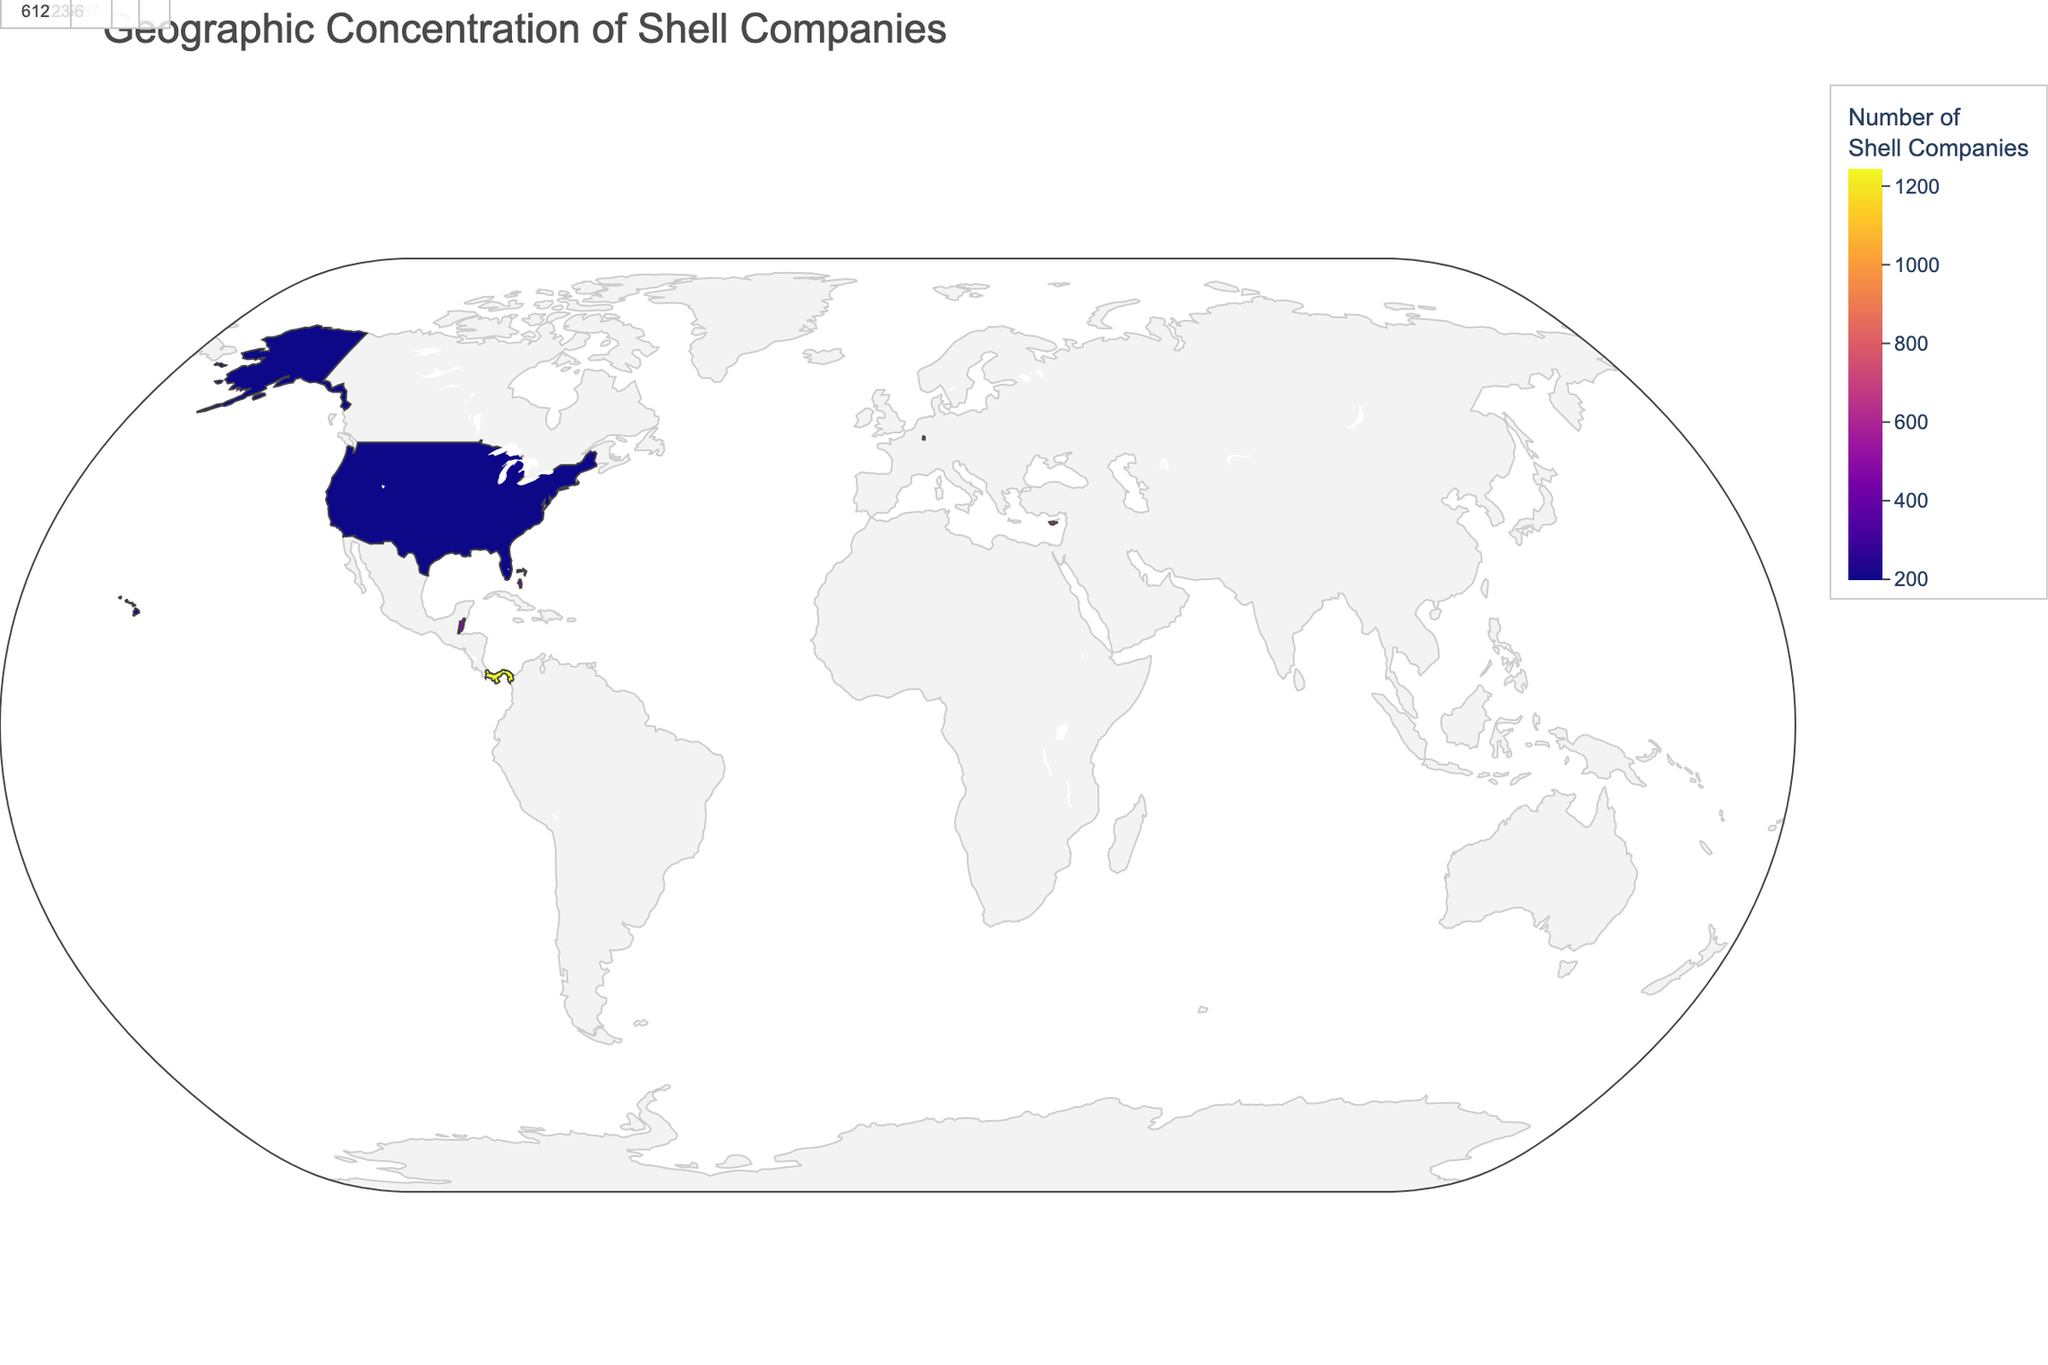How many shell companies are located in Panama? The map includes a tooltip with the number of shell companies for each country. In Panama, the tooltip shows that there are 1245 shell companies.
Answer: 1245 What color represents regions with the highest number of shell companies? The color scale used in the map ranges from lighter to darker shades. Darker shades represent regions with a higher number of shell companies.
Answer: Darker shades What is the primary connection for shell companies located in the British Virgin Islands? When hovering over the British Virgin Islands, the tooltip reveals that the primary connection for shell companies here is Offshore Banking.
Answer: Offshore Banking Which country has the lowest number of shell companies among those listed? By checking the numbers associated with each country, Delaware (USA) reveals the lowest value of 198 shell companies.
Answer: Delaware (USA) How many more shell companies are there in the Cayman Islands compared to Cyprus? According to the tooltip data, the Cayman Islands have 856 shell companies, while Cyprus has 612. The difference is obtained by subtracting the two values: 856 - 612.
Answer: 244 List the top three countries with the highest number of shell companies and their primary connections. Referring to the top values in the tooltip data, the top three countries are Panama (1245, Tax Haven), British Virgin Islands (987, Offshore Banking), and Cayman Islands (856, Investment Funds).
Answer: Panama, British Virgin Islands, Cayman Islands What is the total number of shell companies across all countries shown in the map? Add the number of shell companies for all countries listed: 1245 (Panama) + 987 (British Virgin Islands) + 856 (Cayman Islands) + 723 (Luxembourg) + 612 (Cyprus) + 534 (Seychelles) + 478 (Belize) + 423 (Bahamas) + 389 (Jersey) + 356 (Isle of Man) + 312 (Hong Kong) + 287 (Singapore) + 245 (Liechtenstein) + 213 (Malta) + 198 (Delaware). The sum is 7858.
Answer: 7858 Which country has the primary connection with "Real Estate Holdings" and how many shell companies does it have? Hovering over the Bahamas reveals that its primary connection is Real Estate Holdings and it has 423 shell companies.
Answer: Bahamas, 423 Compare the number of shell companies in Luxembourg and Belize. Which one has more, and by how many? Luxembourg has 723 shell companies, while Belize has 478. The difference is calculated by subtracting 478 from 723.
Answer: Luxembourg, 245 How are the countries with the top 5 numbers of shell companies highlighted on the map? The top 5 countries with the highest number of shell companies are annotated with their names and values directly on the map for easy identification.
Answer: Annotated 